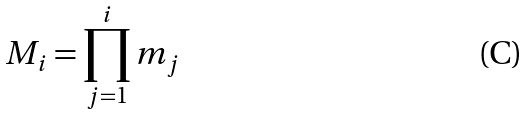<formula> <loc_0><loc_0><loc_500><loc_500>M _ { i } = \prod _ { j = 1 } ^ { i } m _ { j }</formula> 